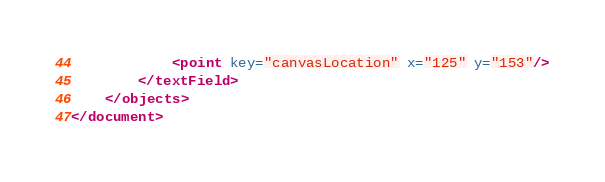<code> <loc_0><loc_0><loc_500><loc_500><_XML_>            <point key="canvasLocation" x="125" y="153"/>
        </textField>
    </objects>
</document>
</code> 